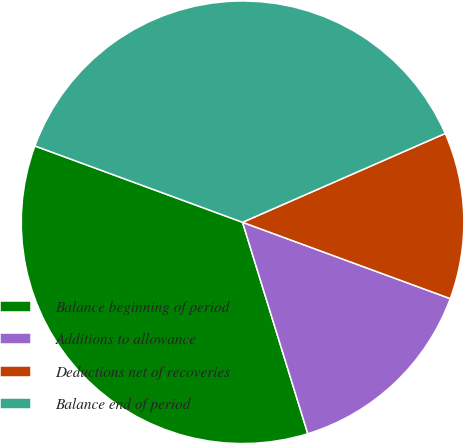Convert chart. <chart><loc_0><loc_0><loc_500><loc_500><pie_chart><fcel>Balance beginning of period<fcel>Additions to allowance<fcel>Deductions net of recoveries<fcel>Balance end of period<nl><fcel>35.37%<fcel>14.63%<fcel>12.18%<fcel>37.82%<nl></chart> 